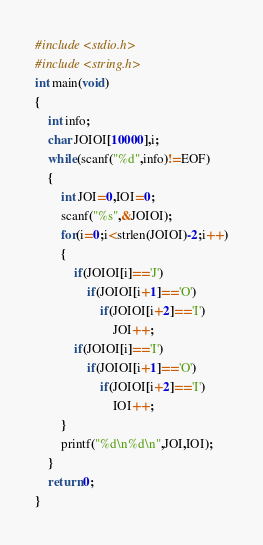<code> <loc_0><loc_0><loc_500><loc_500><_C_>#include <stdio.h>
#include <string.h>
int main(void)
{
    int info;
    char JOIOI[10000],i;
    while(scanf("%d",info)!=EOF)
    {
        int JOI=0,IOI=0;
        scanf("%s",&JOIOI);
        for(i=0;i<strlen(JOIOI)-2;i++)
        {
            if(JOIOI[i]=='J')
                if(JOIOI[i+1]=='O')
                    if(JOIOI[i+2]=='I')
                        JOI++;
            if(JOIOI[i]=='I')
                if(JOIOI[i+1]=='O')
                    if(JOIOI[i+2]=='I')
                        IOI++;
        }
        printf("%d\n%d\n",JOI,IOI);
    }
    return 0;
}</code> 